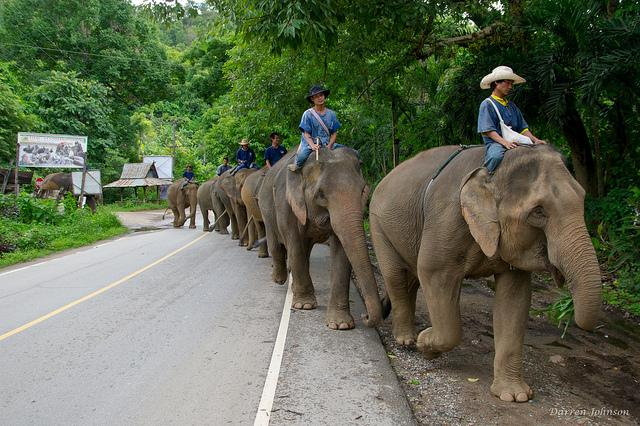What is on top of the elephants? people 